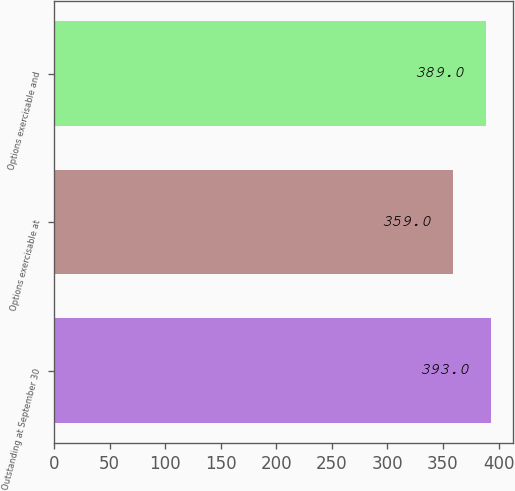Convert chart. <chart><loc_0><loc_0><loc_500><loc_500><bar_chart><fcel>Outstanding at September 30<fcel>Options exercisable at<fcel>Options exercisable and<nl><fcel>393<fcel>359<fcel>389<nl></chart> 